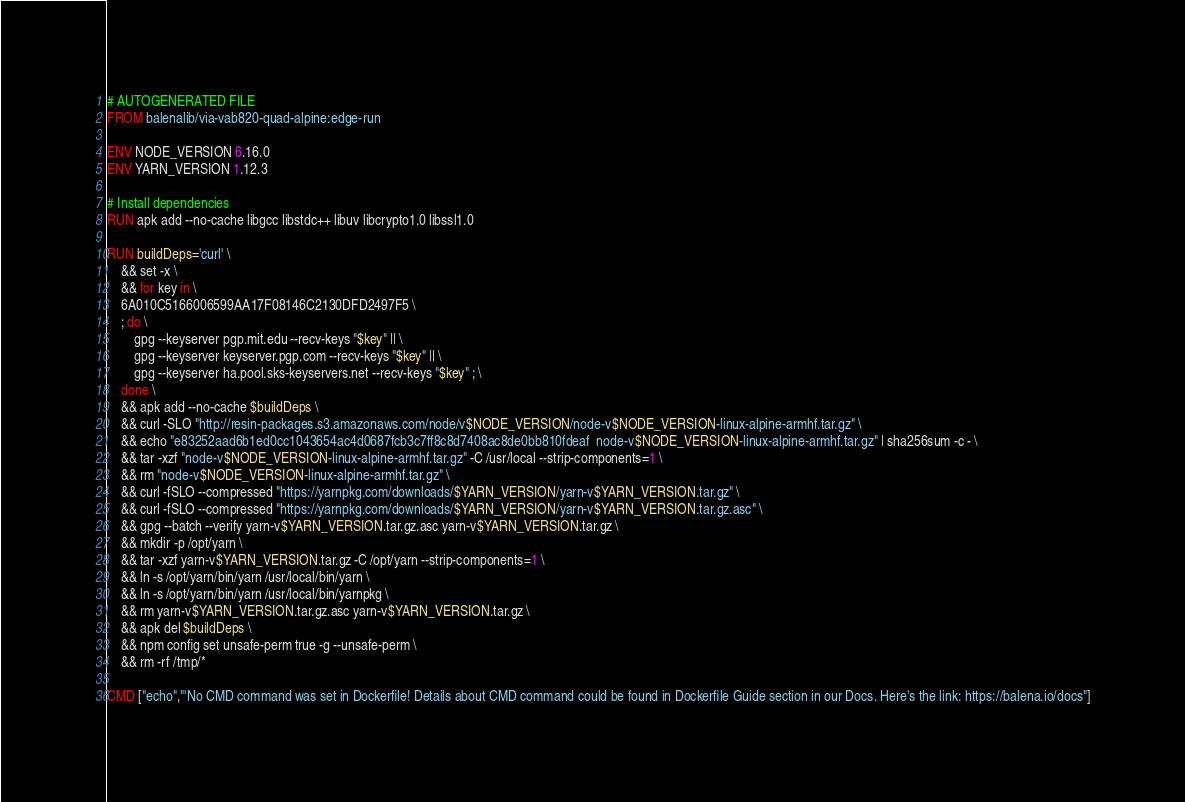Convert code to text. <code><loc_0><loc_0><loc_500><loc_500><_Dockerfile_># AUTOGENERATED FILE
FROM balenalib/via-vab820-quad-alpine:edge-run

ENV NODE_VERSION 6.16.0
ENV YARN_VERSION 1.12.3

# Install dependencies
RUN apk add --no-cache libgcc libstdc++ libuv libcrypto1.0 libssl1.0

RUN buildDeps='curl' \
	&& set -x \
	&& for key in \
	6A010C5166006599AA17F08146C2130DFD2497F5 \
	; do \
		gpg --keyserver pgp.mit.edu --recv-keys "$key" || \
		gpg --keyserver keyserver.pgp.com --recv-keys "$key" || \
		gpg --keyserver ha.pool.sks-keyservers.net --recv-keys "$key" ; \
	done \
	&& apk add --no-cache $buildDeps \
	&& curl -SLO "http://resin-packages.s3.amazonaws.com/node/v$NODE_VERSION/node-v$NODE_VERSION-linux-alpine-armhf.tar.gz" \
	&& echo "e83252aad6b1ed0cc1043654ac4d0687fcb3c7ff8c8d7408ac8de0bb810fdeaf  node-v$NODE_VERSION-linux-alpine-armhf.tar.gz" | sha256sum -c - \
	&& tar -xzf "node-v$NODE_VERSION-linux-alpine-armhf.tar.gz" -C /usr/local --strip-components=1 \
	&& rm "node-v$NODE_VERSION-linux-alpine-armhf.tar.gz" \
	&& curl -fSLO --compressed "https://yarnpkg.com/downloads/$YARN_VERSION/yarn-v$YARN_VERSION.tar.gz" \
	&& curl -fSLO --compressed "https://yarnpkg.com/downloads/$YARN_VERSION/yarn-v$YARN_VERSION.tar.gz.asc" \
	&& gpg --batch --verify yarn-v$YARN_VERSION.tar.gz.asc yarn-v$YARN_VERSION.tar.gz \
	&& mkdir -p /opt/yarn \
	&& tar -xzf yarn-v$YARN_VERSION.tar.gz -C /opt/yarn --strip-components=1 \
	&& ln -s /opt/yarn/bin/yarn /usr/local/bin/yarn \
	&& ln -s /opt/yarn/bin/yarn /usr/local/bin/yarnpkg \
	&& rm yarn-v$YARN_VERSION.tar.gz.asc yarn-v$YARN_VERSION.tar.gz \
	&& apk del $buildDeps \
	&& npm config set unsafe-perm true -g --unsafe-perm \
	&& rm -rf /tmp/*

CMD ["echo","'No CMD command was set in Dockerfile! Details about CMD command could be found in Dockerfile Guide section in our Docs. Here's the link: https://balena.io/docs"]</code> 